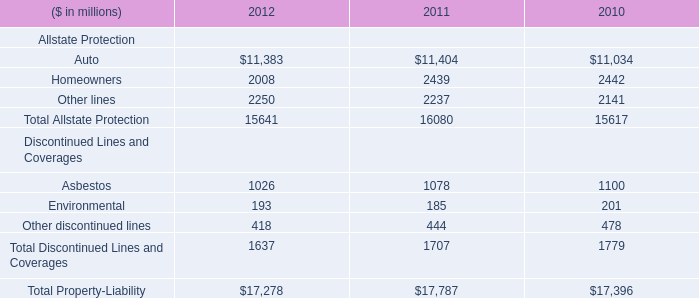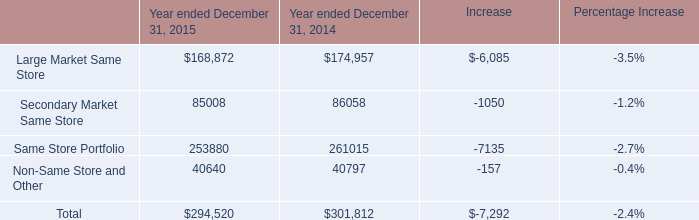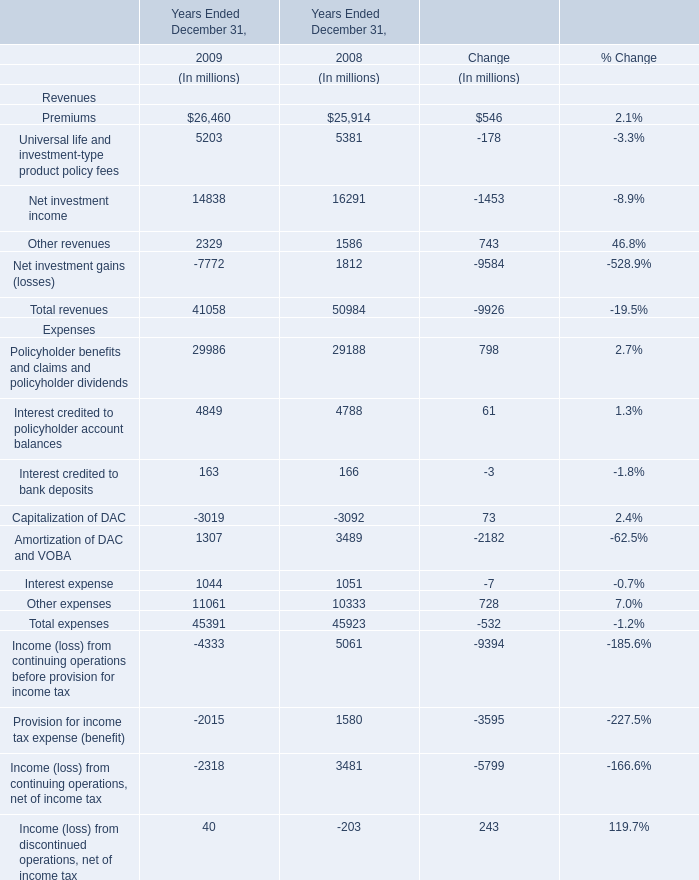What's the growth rate of Other revenues in 2009 Ended December 31? 
Computations: ((2329 - 1586) / 1586)
Answer: 0.46847. 